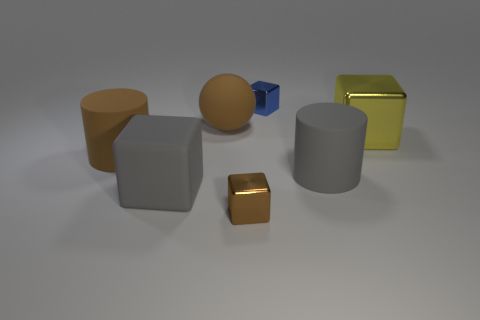Are there any shiny things that have the same size as the gray rubber cylinder?
Offer a terse response. Yes. How many matte things are either brown blocks or blue things?
Ensure brevity in your answer.  0. The large object that is the same color as the matte ball is what shape?
Provide a succinct answer. Cylinder. How many small blue shiny blocks are there?
Provide a short and direct response. 1. Does the object behind the ball have the same material as the big cylinder to the right of the tiny brown shiny thing?
Give a very brief answer. No. There is a brown block that is made of the same material as the blue object; what is its size?
Ensure brevity in your answer.  Small. There is a large brown rubber thing that is left of the brown matte ball; what is its shape?
Ensure brevity in your answer.  Cylinder. Is the color of the shiny block that is on the right side of the big gray rubber cylinder the same as the small metal object that is on the left side of the small blue shiny block?
Provide a succinct answer. No. There is a metal thing that is the same color as the big matte ball; what is its size?
Give a very brief answer. Small. Are there any large cylinders?
Keep it short and to the point. Yes. 